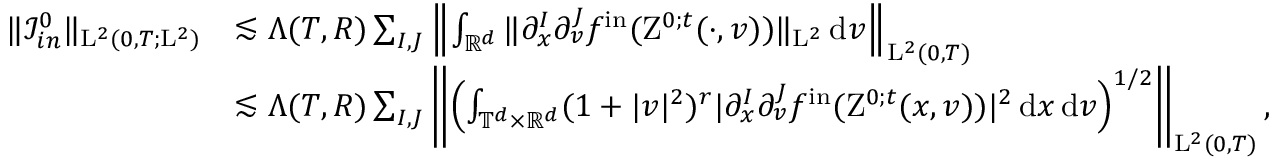<formula> <loc_0><loc_0><loc_500><loc_500>\begin{array} { r l } { \| \mathcal { I } _ { i n } ^ { 0 } \| _ { L ^ { 2 } ( 0 , T ; L ^ { 2 } ) } } & { \lesssim \Lambda ( T , R ) \sum _ { I , J } \left \| \int _ { \mathbb { R } ^ { d } } \| \partial _ { x } ^ { I } \partial _ { v } ^ { J } f ^ { i n } ( Z ^ { 0 ; t } ( \cdot , v ) ) \| _ { L ^ { 2 } } \, d v \right \| _ { L ^ { 2 } ( 0 , T ) } } \\ & { \lesssim \Lambda ( T , R ) \sum _ { I , J } \left \| \left ( \int _ { \mathbb { T } ^ { d } \times \mathbb { R } ^ { d } } ( 1 + | v | ^ { 2 } ) ^ { r } | \partial _ { x } ^ { I } \partial _ { v } ^ { J } f ^ { i n } ( Z ^ { 0 ; t } ( x , v ) ) | ^ { 2 } \, d x \, d v \right ) ^ { 1 / 2 } \right \| _ { L ^ { 2 } ( 0 , T ) } , } \end{array}</formula> 